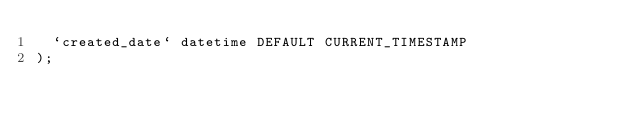<code> <loc_0><loc_0><loc_500><loc_500><_SQL_>  `created_date` datetime DEFAULT CURRENT_TIMESTAMP
);
</code> 